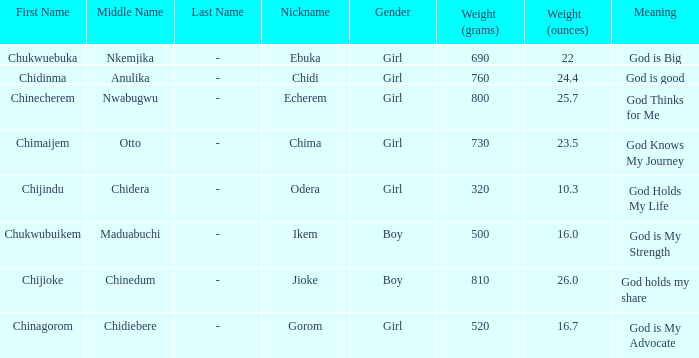Which moniker signifies that god is aware of my path? Chima. 